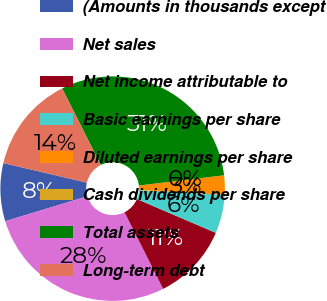Convert chart to OTSL. <chart><loc_0><loc_0><loc_500><loc_500><pie_chart><fcel>(Amounts in thousands except<fcel>Net sales<fcel>Net income attributable to<fcel>Basic earnings per share<fcel>Diluted earnings per share<fcel>Cash dividends per share<fcel>Total assets<fcel>Long-term debt<nl><fcel>8.35%<fcel>27.75%<fcel>11.13%<fcel>5.56%<fcel>2.78%<fcel>0.0%<fcel>30.53%<fcel>13.91%<nl></chart> 